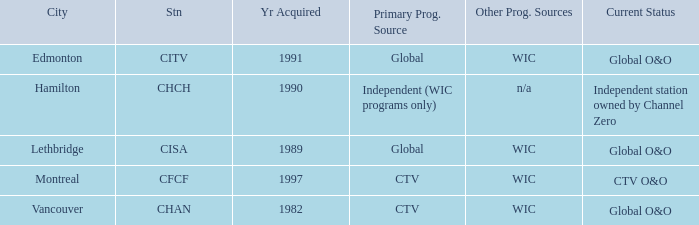How many channels were gained in 1997 1.0. 